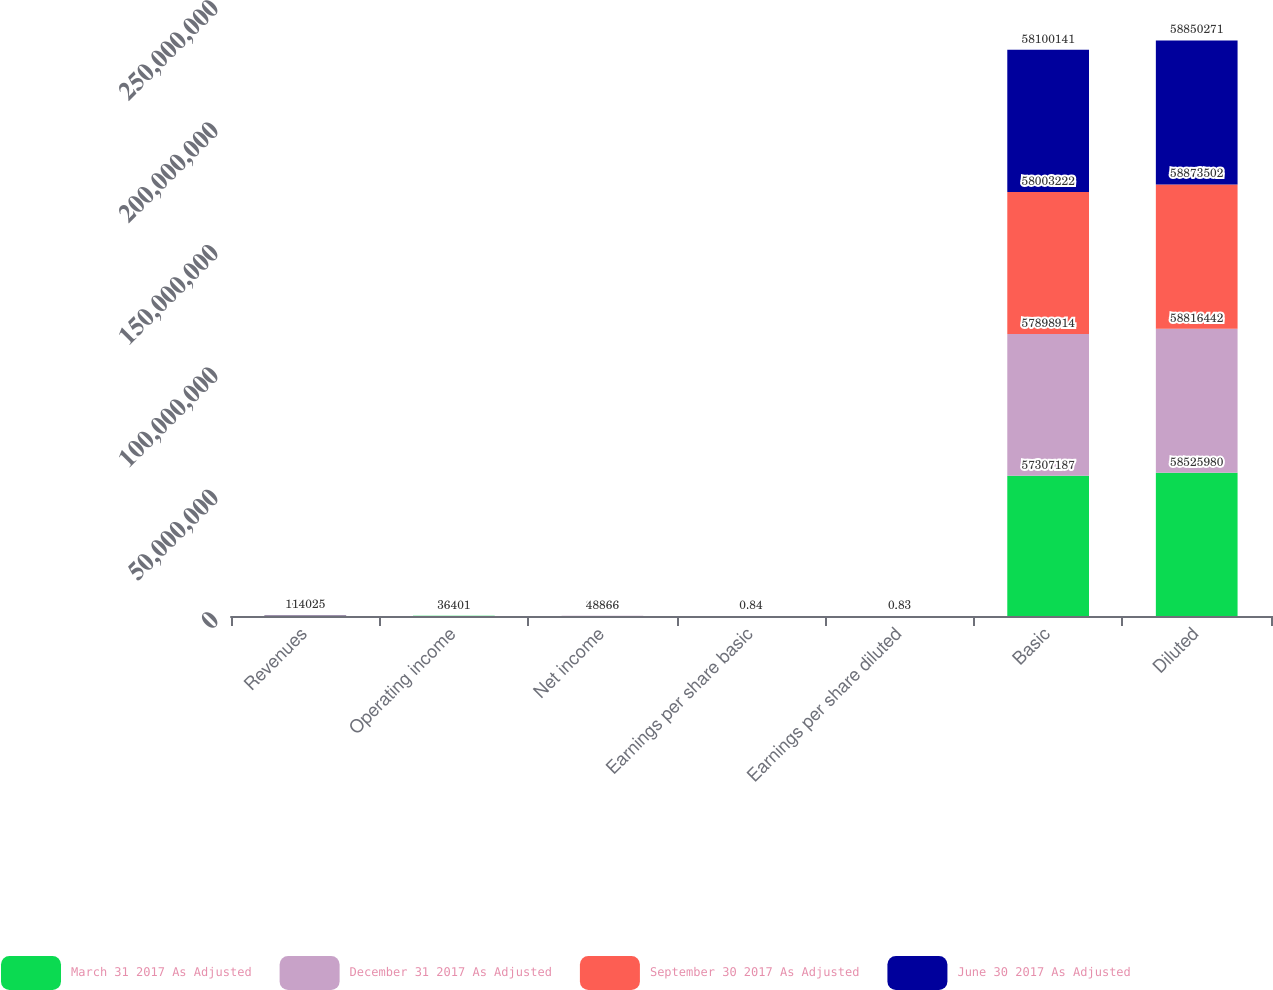<chart> <loc_0><loc_0><loc_500><loc_500><stacked_bar_chart><ecel><fcel>Revenues<fcel>Operating income<fcel>Net income<fcel>Earnings per share basic<fcel>Earnings per share diluted<fcel>Basic<fcel>Diluted<nl><fcel>March 31 2017 As Adjusted<fcel>119508<fcel>52510<fcel>33694<fcel>0.58<fcel>0.57<fcel>5.73072e+07<fcel>5.8526e+07<nl><fcel>December 31 2017 As Adjusted<fcel>98227<fcel>18792<fcel>20016<fcel>0.34<fcel>0.34<fcel>5.78989e+07<fcel>5.88164e+07<nl><fcel>September 30 2017 As Adjusted<fcel>101287<fcel>22007<fcel>20910<fcel>0.36<fcel>0.35<fcel>5.80032e+07<fcel>5.88735e+07<nl><fcel>June 30 2017 As Adjusted<fcel>114025<fcel>36401<fcel>48866<fcel>0.84<fcel>0.83<fcel>5.81001e+07<fcel>5.88503e+07<nl></chart> 